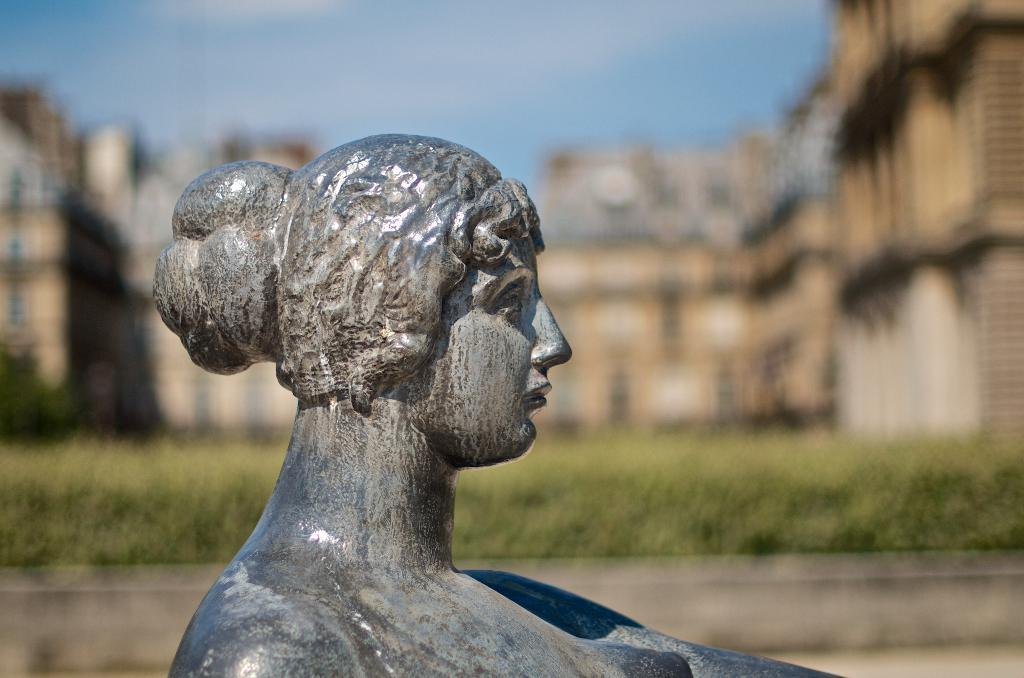What is the main subject of the image? There is a statue of a lady in the image. What can be seen in the background of the image? There are buildings behind the statue. What type of vegetation is visible in the image? There is grass visible in the image. What is the color of the sky in the image? The sky is blue in color. What month is depicted in the image? There is no indication of a specific month in the image. Can you copy the statue's pose for me? The image is a static representation, and I am not physically present to replicate the statue's pose. 